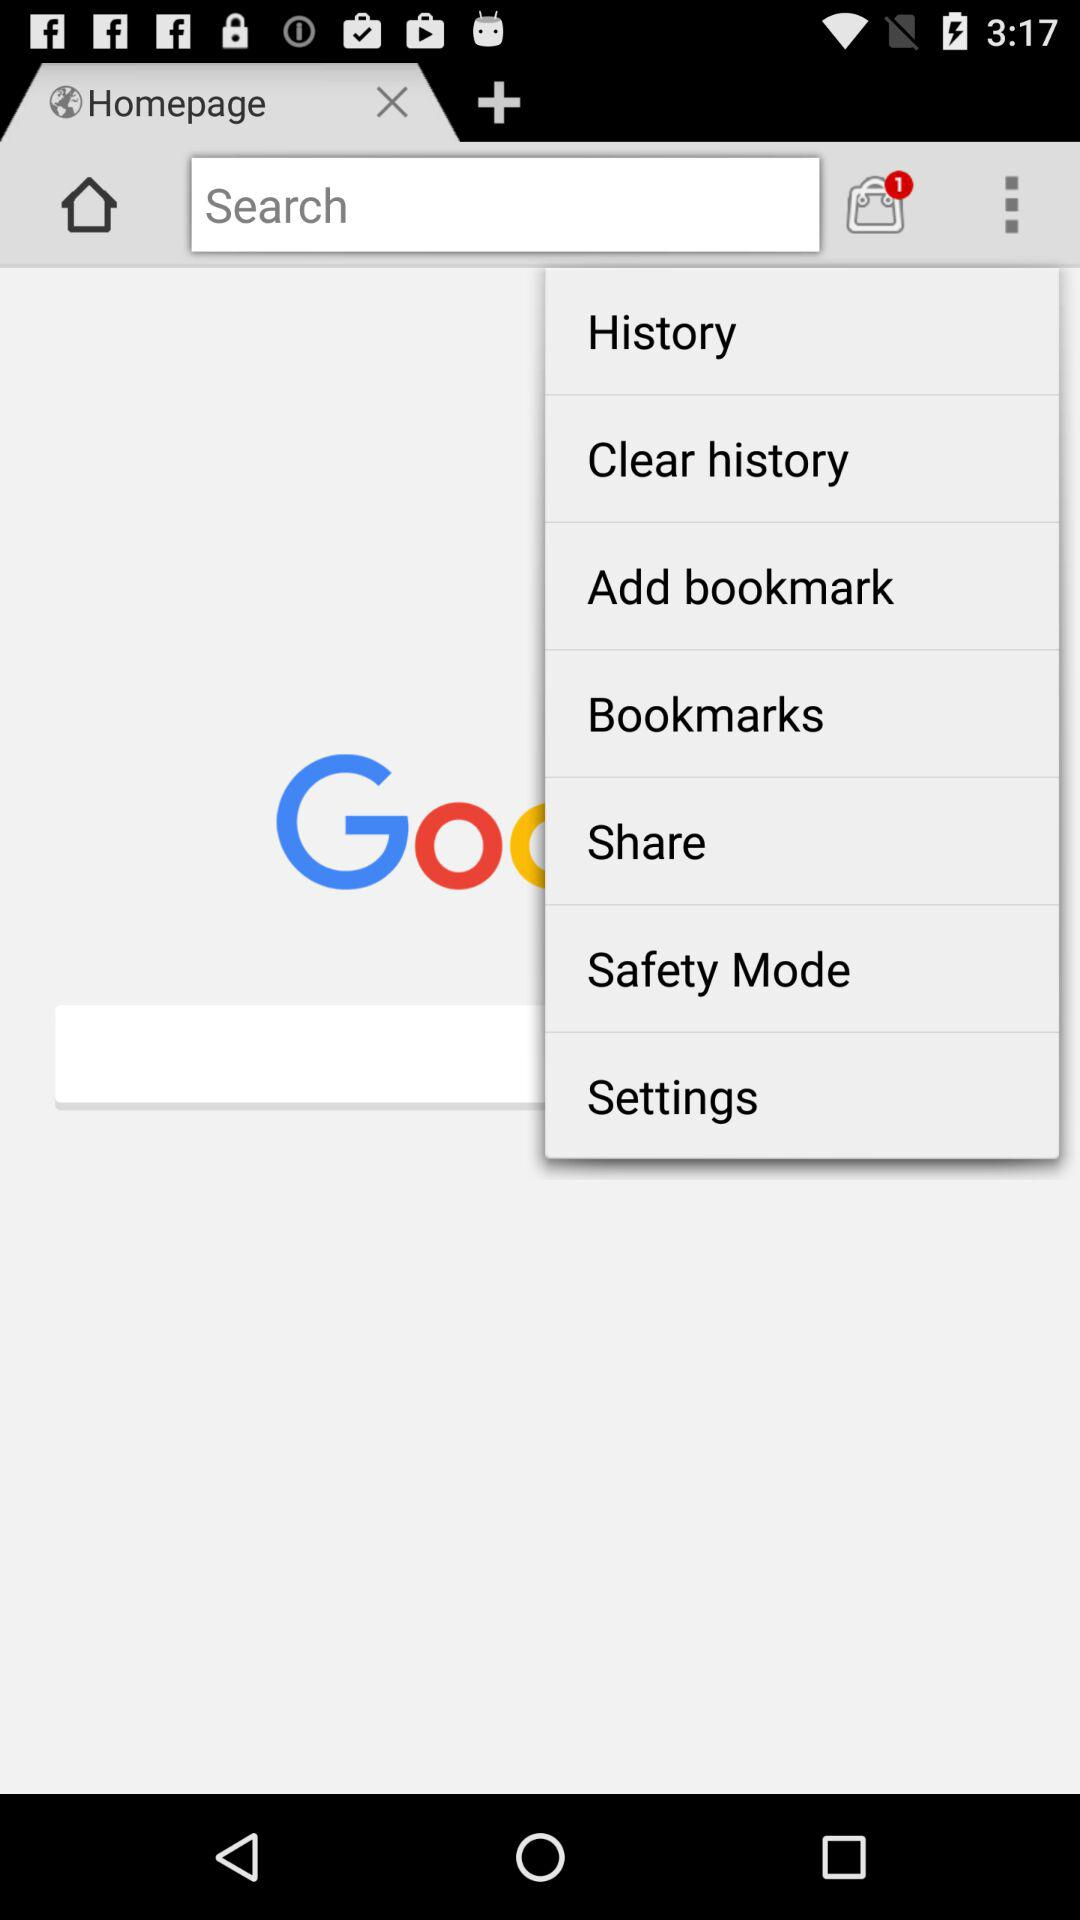How many tabs are currently open? Currently, only 1 tab is open. 